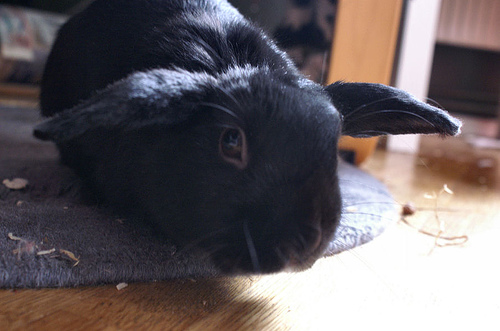<image>
Is there a light on the bunny? Yes. Looking at the image, I can see the light is positioned on top of the bunny, with the bunny providing support. 